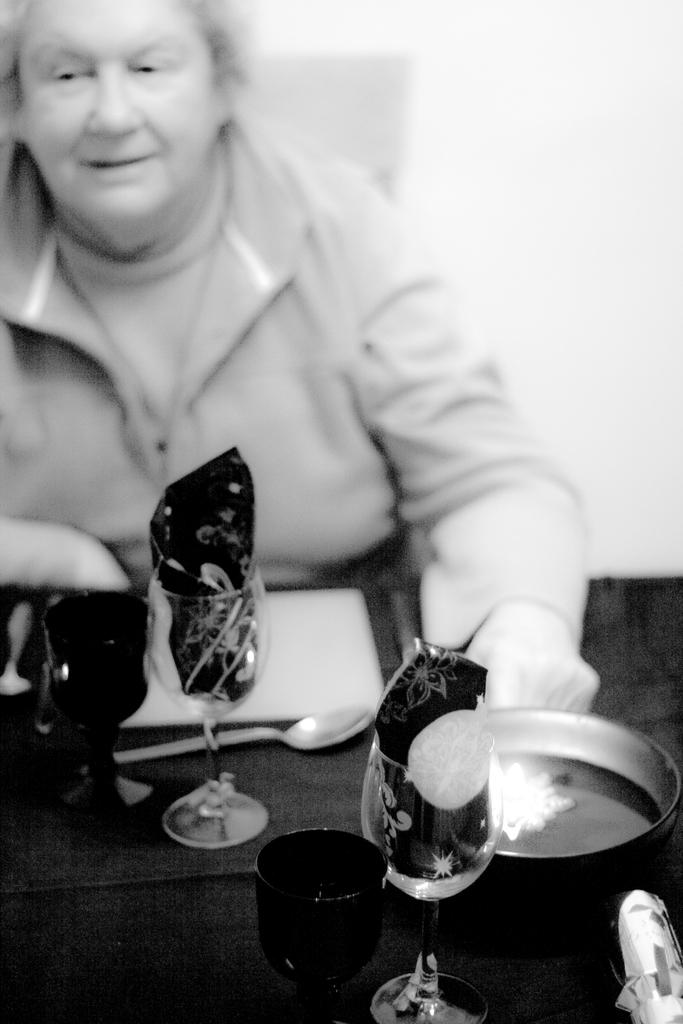Who is present in the image? There is a woman in the image. What is the woman wearing? The woman is wearing a jacket. What is the woman doing in the image? The woman is sitting on a chair. What can be seen on the table in the image? There are drinks, a plate, spoons, and tissues on the table. What type of toothpaste is being used to measure the ingredients in the image? There is no toothpaste or measuring activity present in the image. 